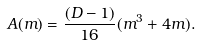Convert formula to latex. <formula><loc_0><loc_0><loc_500><loc_500>A ( m ) = \frac { ( D - 1 ) } { 1 6 } ( m ^ { 3 } + 4 m ) .</formula> 